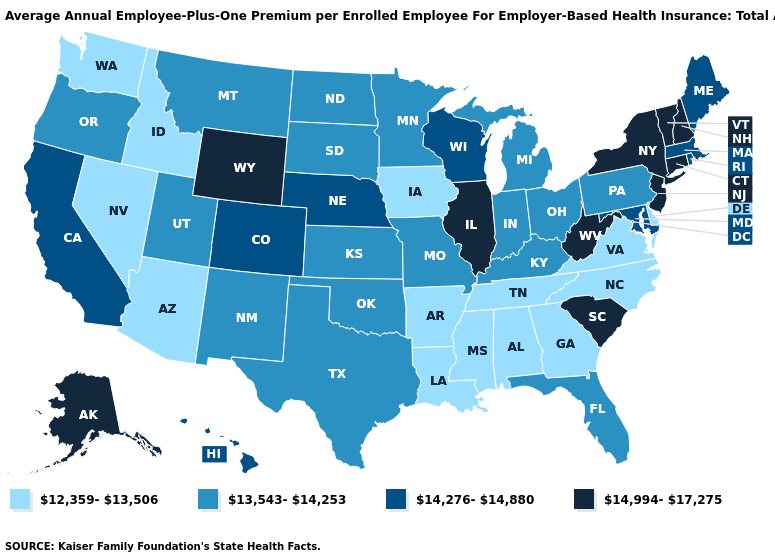Name the states that have a value in the range 14,276-14,880?
Keep it brief. California, Colorado, Hawaii, Maine, Maryland, Massachusetts, Nebraska, Rhode Island, Wisconsin. What is the value of Georgia?
Answer briefly. 12,359-13,506. What is the highest value in states that border New Mexico?
Quick response, please. 14,276-14,880. Does the first symbol in the legend represent the smallest category?
Quick response, please. Yes. What is the value of Vermont?
Give a very brief answer. 14,994-17,275. Does Florida have the highest value in the USA?
Short answer required. No. Name the states that have a value in the range 13,543-14,253?
Quick response, please. Florida, Indiana, Kansas, Kentucky, Michigan, Minnesota, Missouri, Montana, New Mexico, North Dakota, Ohio, Oklahoma, Oregon, Pennsylvania, South Dakota, Texas, Utah. How many symbols are there in the legend?
Be succinct. 4. Name the states that have a value in the range 12,359-13,506?
Be succinct. Alabama, Arizona, Arkansas, Delaware, Georgia, Idaho, Iowa, Louisiana, Mississippi, Nevada, North Carolina, Tennessee, Virginia, Washington. What is the value of Connecticut?
Concise answer only. 14,994-17,275. How many symbols are there in the legend?
Short answer required. 4. What is the highest value in the South ?
Answer briefly. 14,994-17,275. Which states have the highest value in the USA?
Give a very brief answer. Alaska, Connecticut, Illinois, New Hampshire, New Jersey, New York, South Carolina, Vermont, West Virginia, Wyoming. Name the states that have a value in the range 14,276-14,880?
Keep it brief. California, Colorado, Hawaii, Maine, Maryland, Massachusetts, Nebraska, Rhode Island, Wisconsin. Name the states that have a value in the range 12,359-13,506?
Answer briefly. Alabama, Arizona, Arkansas, Delaware, Georgia, Idaho, Iowa, Louisiana, Mississippi, Nevada, North Carolina, Tennessee, Virginia, Washington. 